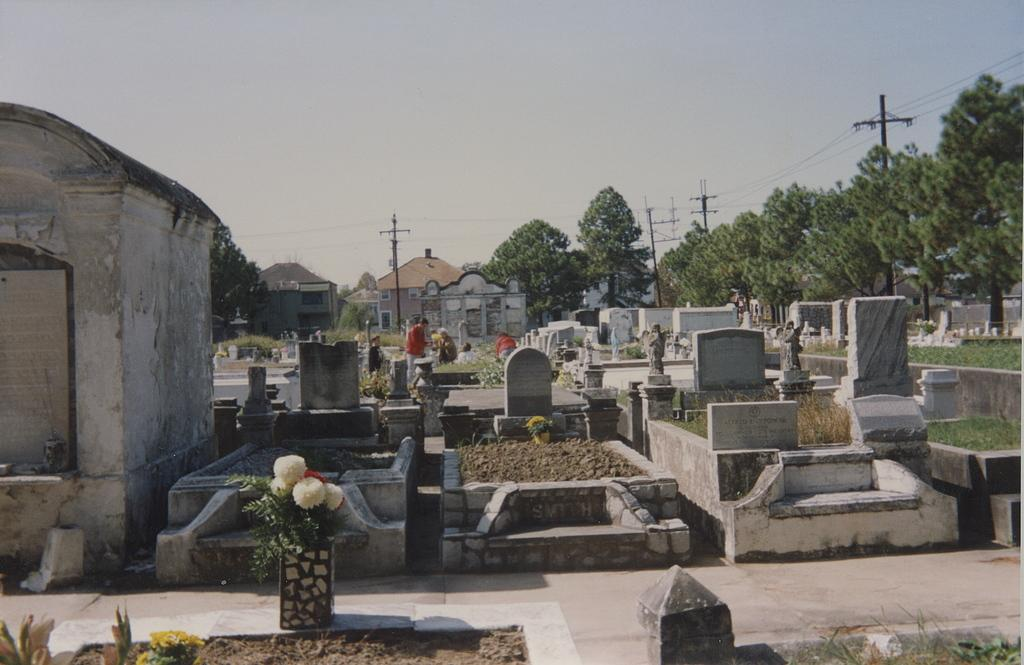What can be seen in the image that represents a final resting place? There are graves in the image. Who is present in the image? There are people in the image. What can be seen in the distance in the image? There are houses, trees, and poles in the background of the image. What type of book is being read by the people in the image? There is no book present in the image; it features graves, people, houses, trees, and poles in the background. How do the people in the image plan to improve their education? There is no indication in the image that the people are focused on education or any related activities. 